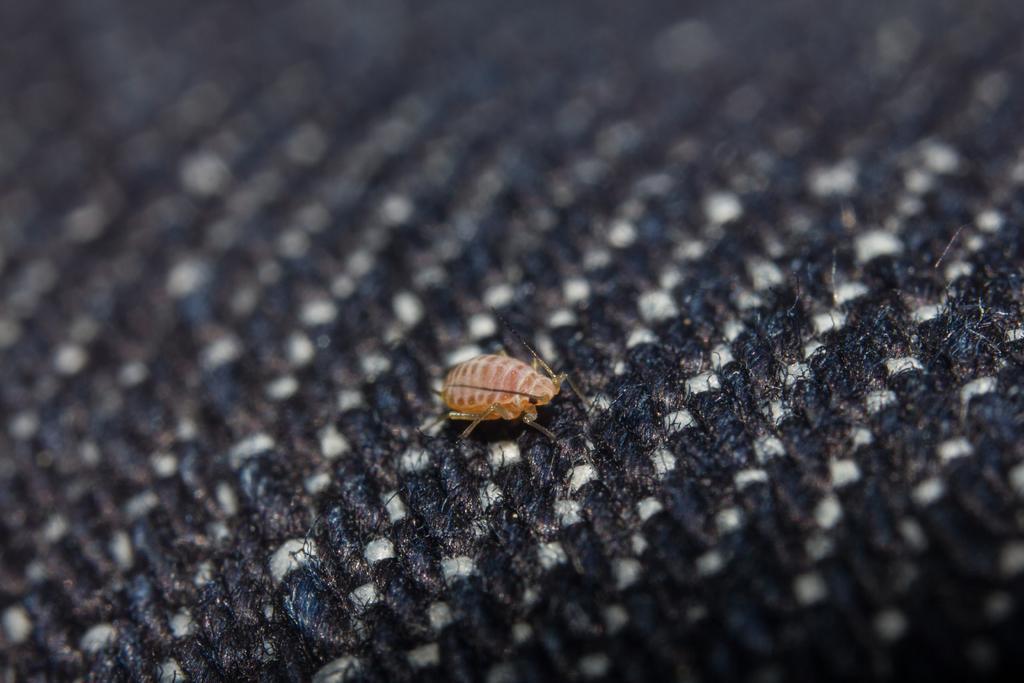Please provide a concise description of this image. In this image we can see an insect on the cloth. 